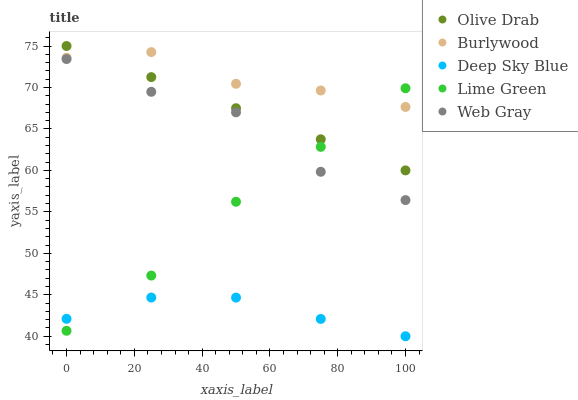Does Deep Sky Blue have the minimum area under the curve?
Answer yes or no. Yes. Does Burlywood have the maximum area under the curve?
Answer yes or no. Yes. Does Web Gray have the minimum area under the curve?
Answer yes or no. No. Does Web Gray have the maximum area under the curve?
Answer yes or no. No. Is Olive Drab the smoothest?
Answer yes or no. Yes. Is Web Gray the roughest?
Answer yes or no. Yes. Is Lime Green the smoothest?
Answer yes or no. No. Is Lime Green the roughest?
Answer yes or no. No. Does Deep Sky Blue have the lowest value?
Answer yes or no. Yes. Does Web Gray have the lowest value?
Answer yes or no. No. Does Olive Drab have the highest value?
Answer yes or no. Yes. Does Web Gray have the highest value?
Answer yes or no. No. Is Deep Sky Blue less than Web Gray?
Answer yes or no. Yes. Is Burlywood greater than Web Gray?
Answer yes or no. Yes. Does Lime Green intersect Olive Drab?
Answer yes or no. Yes. Is Lime Green less than Olive Drab?
Answer yes or no. No. Is Lime Green greater than Olive Drab?
Answer yes or no. No. Does Deep Sky Blue intersect Web Gray?
Answer yes or no. No. 